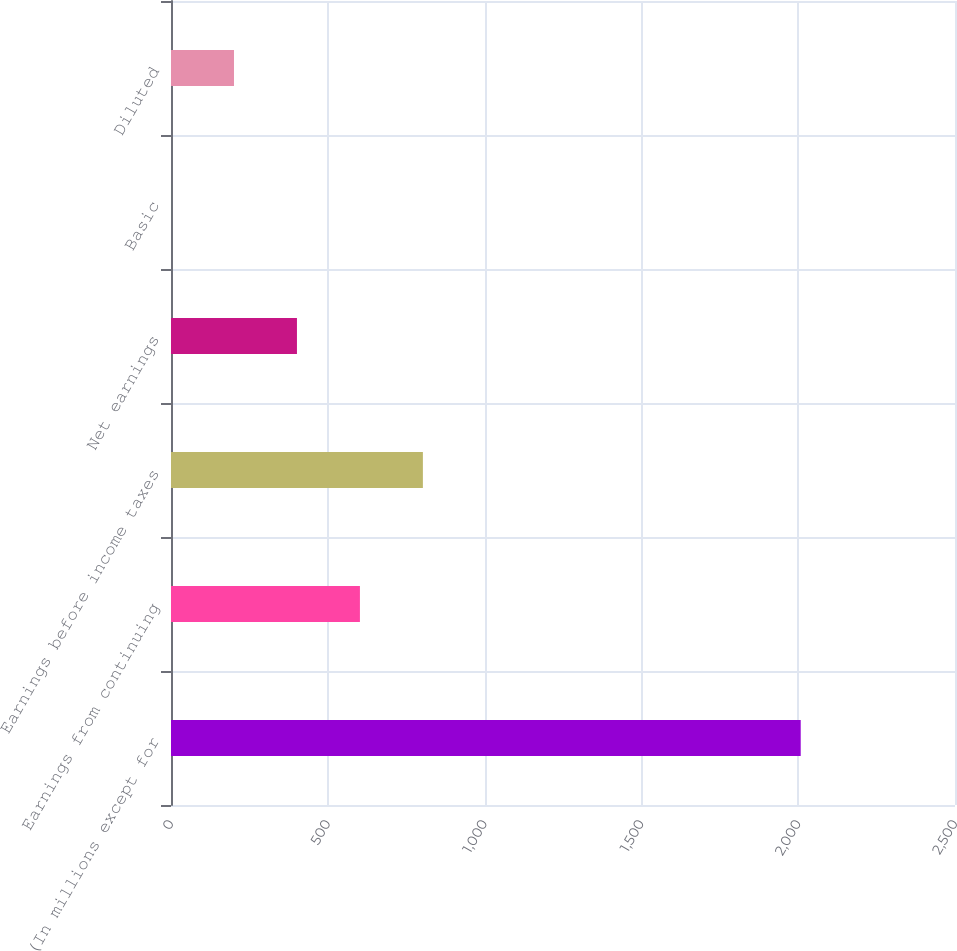<chart> <loc_0><loc_0><loc_500><loc_500><bar_chart><fcel>(In millions except for<fcel>Earnings from continuing<fcel>Earnings before income taxes<fcel>Net earnings<fcel>Basic<fcel>Diluted<nl><fcel>2008<fcel>602.43<fcel>803.22<fcel>401.64<fcel>0.06<fcel>200.85<nl></chart> 